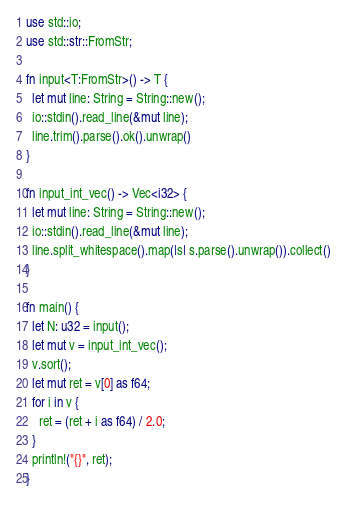Convert code to text. <code><loc_0><loc_0><loc_500><loc_500><_Rust_>use std::io;
use std::str::FromStr;

fn input<T:FromStr>() -> T {
  let mut line: String = String::new();
  io::stdin().read_line(&mut line);
  line.trim().parse().ok().unwrap()
}

fn input_int_vec() -> Vec<i32> {
  let mut line: String = String::new();
  io::stdin().read_line(&mut line);
  line.split_whitespace().map(|s| s.parse().unwrap()).collect()
}

fn main() {
  let N: u32 = input();
  let mut v = input_int_vec();
  v.sort();
  let mut ret = v[0] as f64;
  for i in v {
    ret = (ret + i as f64) / 2.0;
  }
  println!("{}", ret);
}
</code> 